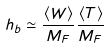Convert formula to latex. <formula><loc_0><loc_0><loc_500><loc_500>h _ { b } \simeq \frac { \langle W \rangle } { M _ { F } } \frac { \langle T \rangle } { M _ { F } }</formula> 